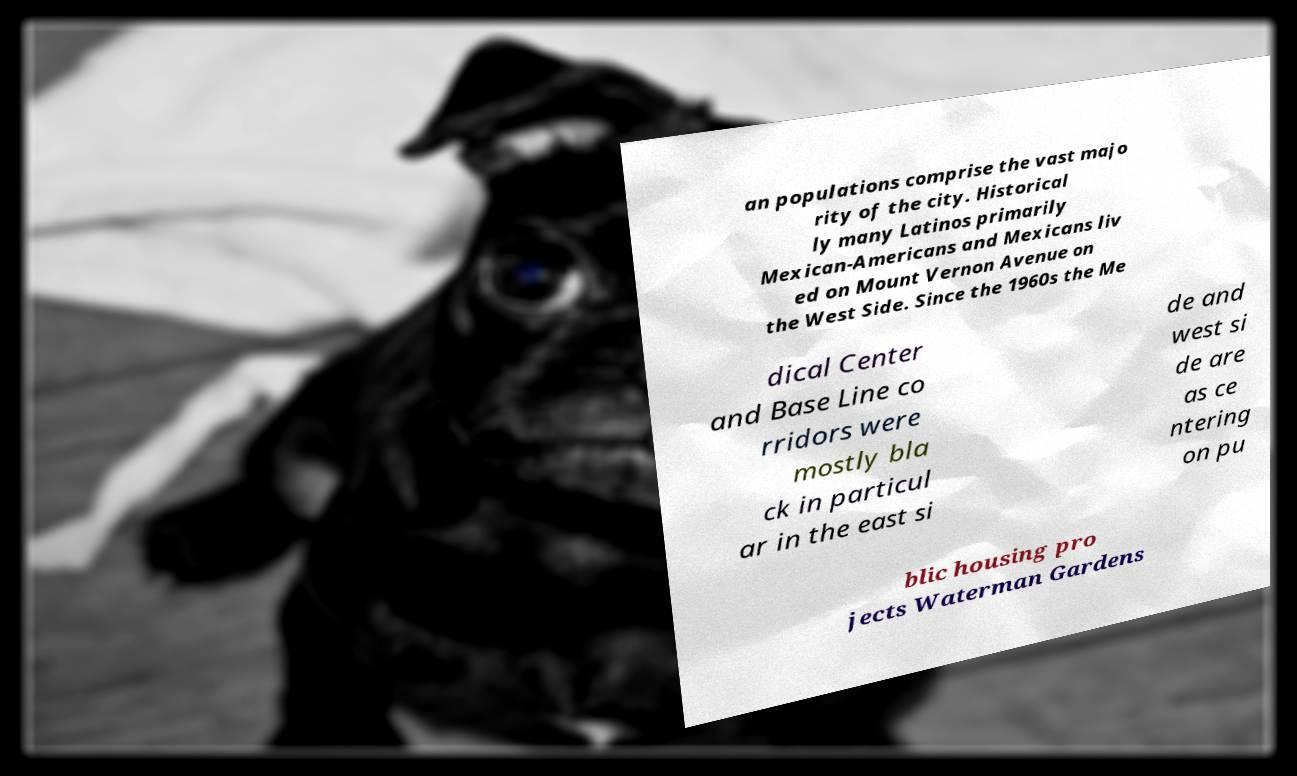What messages or text are displayed in this image? I need them in a readable, typed format. an populations comprise the vast majo rity of the city. Historical ly many Latinos primarily Mexican-Americans and Mexicans liv ed on Mount Vernon Avenue on the West Side. Since the 1960s the Me dical Center and Base Line co rridors were mostly bla ck in particul ar in the east si de and west si de are as ce ntering on pu blic housing pro jects Waterman Gardens 